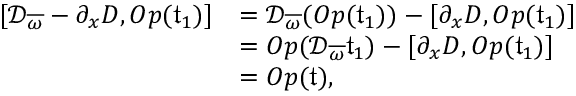<formula> <loc_0><loc_0><loc_500><loc_500>\begin{array} { r l } { [ \mathcal { D } _ { \overline { \omega } } - \partial _ { x } D , O p ( \mathfrak { t } _ { 1 } ) ] } & { = \mathcal { D } _ { \overline { \omega } } ( O p ( \mathfrak { t } _ { 1 } ) ) - [ \partial _ { x } D , O p ( \mathfrak { t } _ { 1 } ) ] } \\ & { = O p ( \mathcal { D } _ { \overline { \omega } } \mathfrak { t } _ { 1 } ) - [ \partial _ { x } D , O p ( \mathfrak { t } _ { 1 } ) ] } \\ & { = O p ( \mathfrak { t } ) , } \end{array}</formula> 